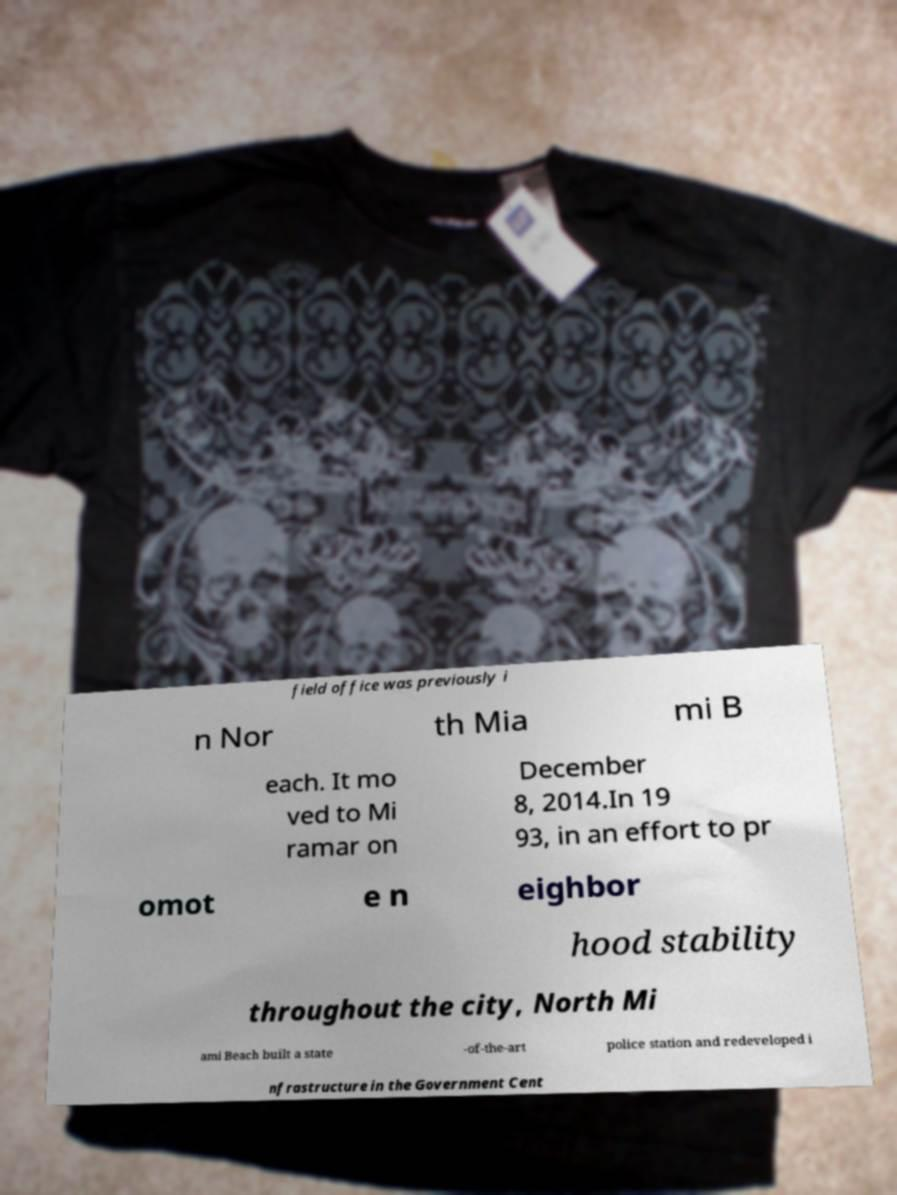Could you assist in decoding the text presented in this image and type it out clearly? field office was previously i n Nor th Mia mi B each. It mo ved to Mi ramar on December 8, 2014.In 19 93, in an effort to pr omot e n eighbor hood stability throughout the city, North Mi ami Beach built a state -of-the-art police station and redeveloped i nfrastructure in the Government Cent 